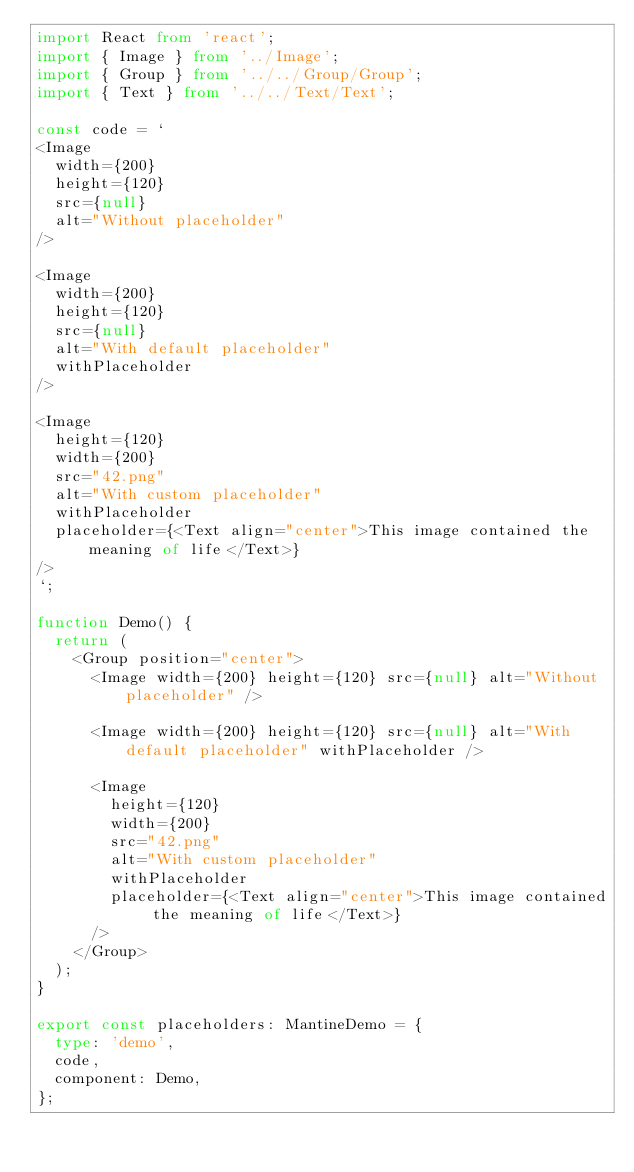<code> <loc_0><loc_0><loc_500><loc_500><_TypeScript_>import React from 'react';
import { Image } from '../Image';
import { Group } from '../../Group/Group';
import { Text } from '../../Text/Text';

const code = `
<Image
  width={200}
  height={120}
  src={null}
  alt="Without placeholder"
/>

<Image
  width={200}
  height={120}
  src={null}
  alt="With default placeholder"
  withPlaceholder
/>

<Image
  height={120}
  width={200}
  src="42.png"
  alt="With custom placeholder"
  withPlaceholder
  placeholder={<Text align="center">This image contained the meaning of life</Text>}
/>
`;

function Demo() {
  return (
    <Group position="center">
      <Image width={200} height={120} src={null} alt="Without placeholder" />

      <Image width={200} height={120} src={null} alt="With default placeholder" withPlaceholder />

      <Image
        height={120}
        width={200}
        src="42.png"
        alt="With custom placeholder"
        withPlaceholder
        placeholder={<Text align="center">This image contained the meaning of life</Text>}
      />
    </Group>
  );
}

export const placeholders: MantineDemo = {
  type: 'demo',
  code,
  component: Demo,
};
</code> 